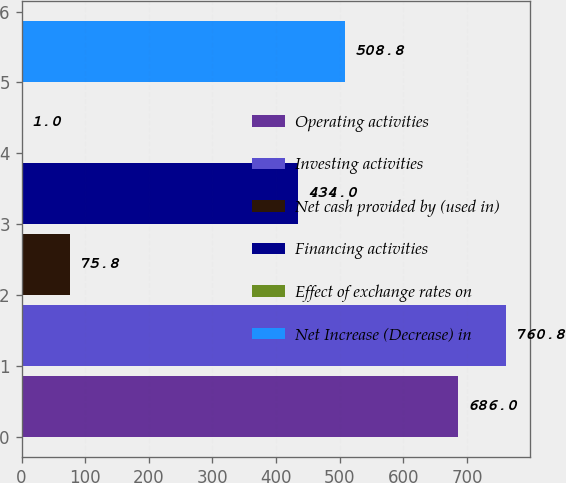Convert chart to OTSL. <chart><loc_0><loc_0><loc_500><loc_500><bar_chart><fcel>Operating activities<fcel>Investing activities<fcel>Net cash provided by (used in)<fcel>Financing activities<fcel>Effect of exchange rates on<fcel>Net Increase (Decrease) in<nl><fcel>686<fcel>760.8<fcel>75.8<fcel>434<fcel>1<fcel>508.8<nl></chart> 